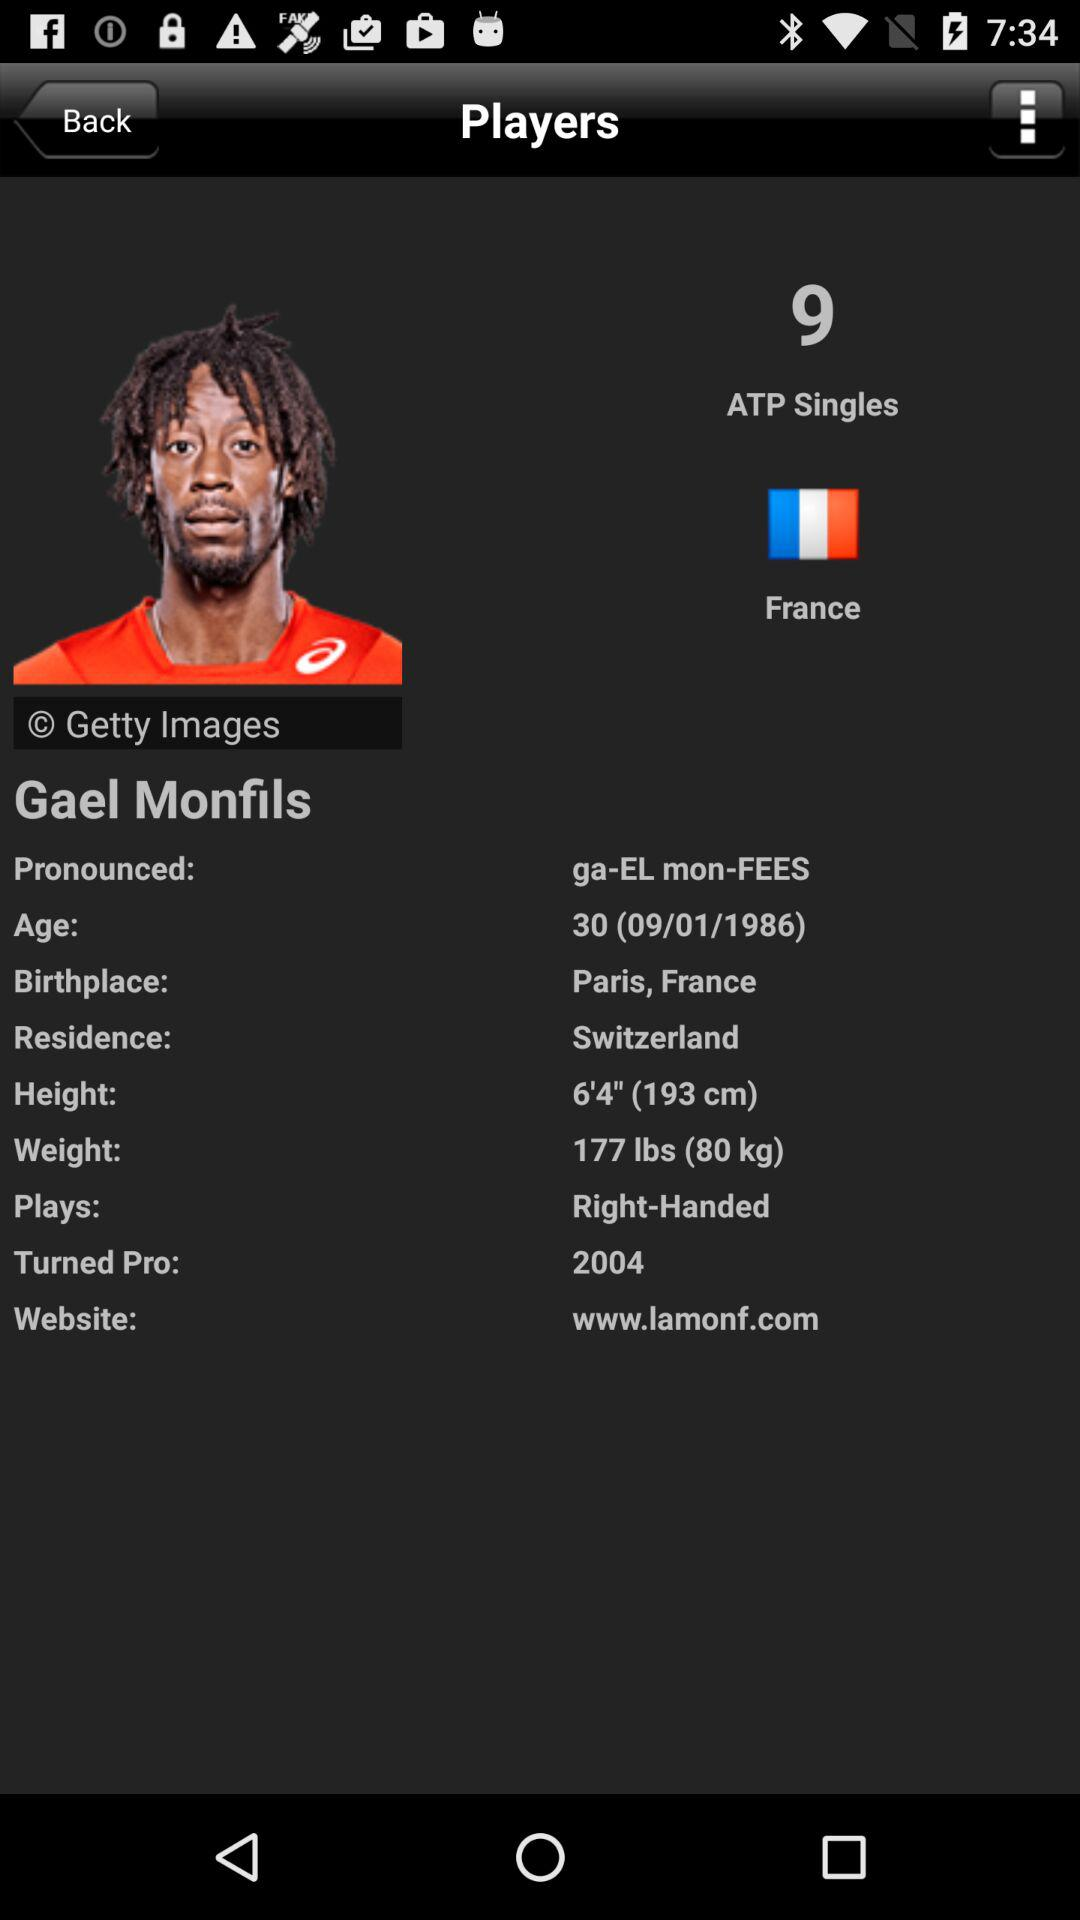When did Gael Monfils turn pro? Gael Monfils turned pro in 2004. 